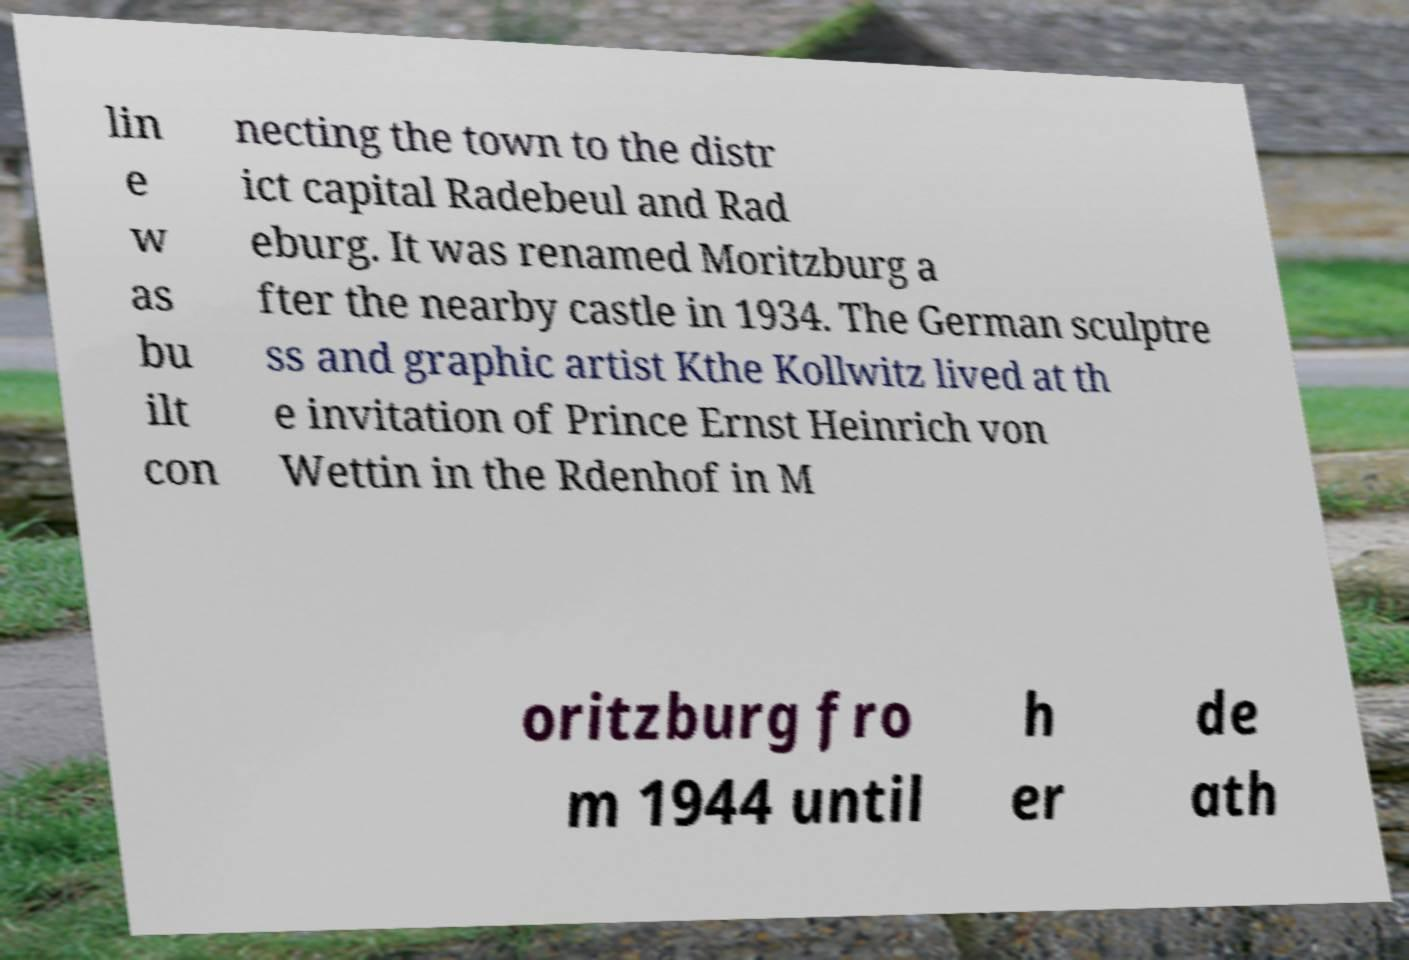For documentation purposes, I need the text within this image transcribed. Could you provide that? lin e w as bu ilt con necting the town to the distr ict capital Radebeul and Rad eburg. It was renamed Moritzburg a fter the nearby castle in 1934. The German sculptre ss and graphic artist Kthe Kollwitz lived at th e invitation of Prince Ernst Heinrich von Wettin in the Rdenhof in M oritzburg fro m 1944 until h er de ath 